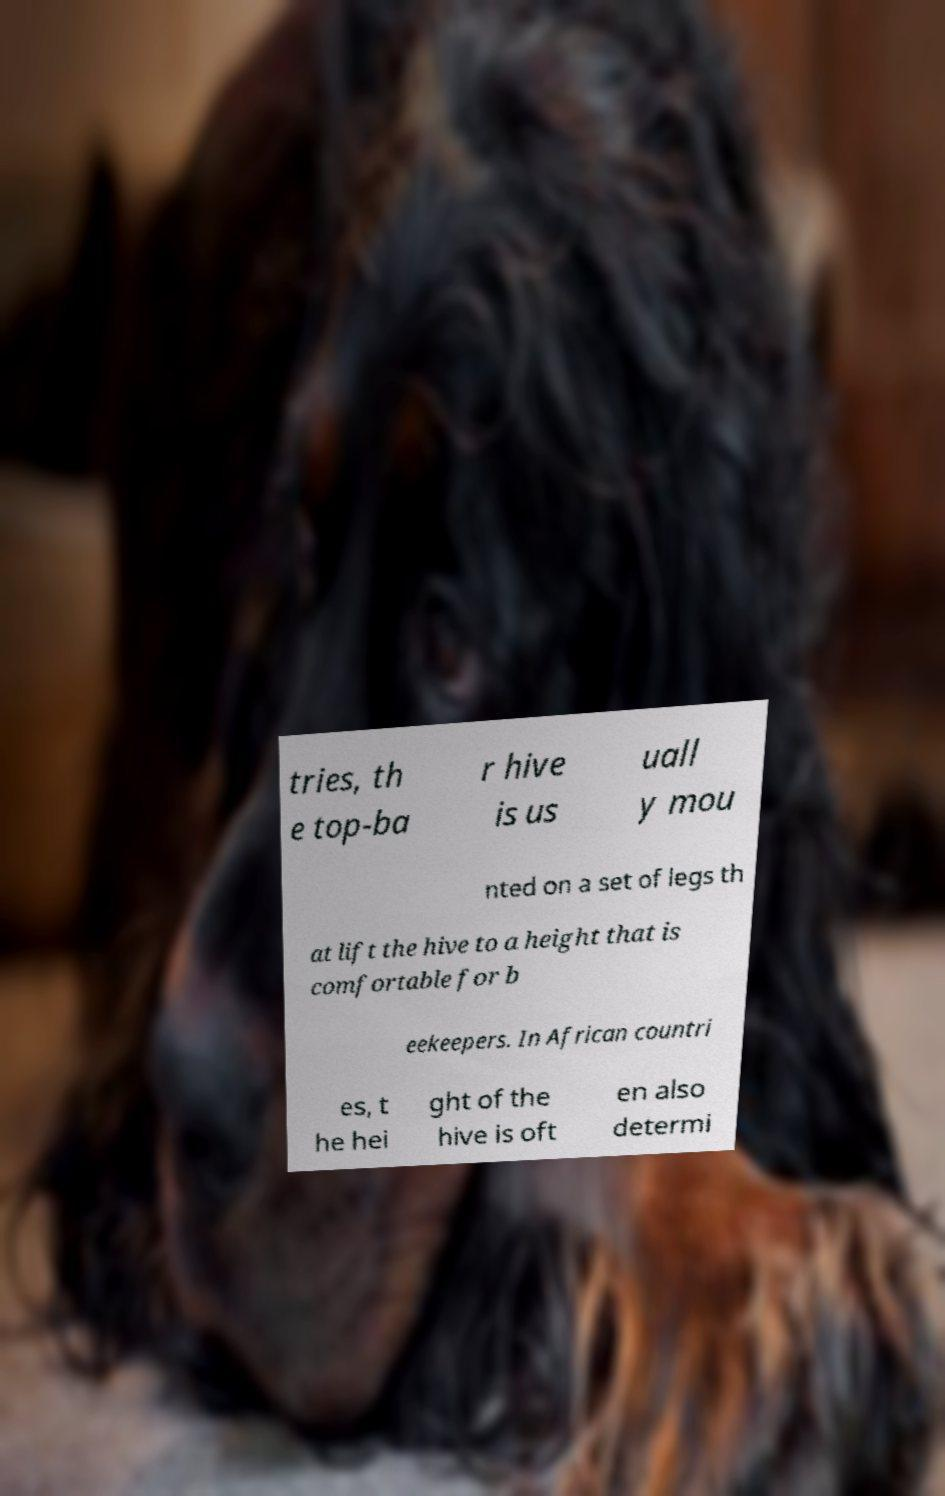Please read and relay the text visible in this image. What does it say? tries, th e top-ba r hive is us uall y mou nted on a set of legs th at lift the hive to a height that is comfortable for b eekeepers. In African countri es, t he hei ght of the hive is oft en also determi 